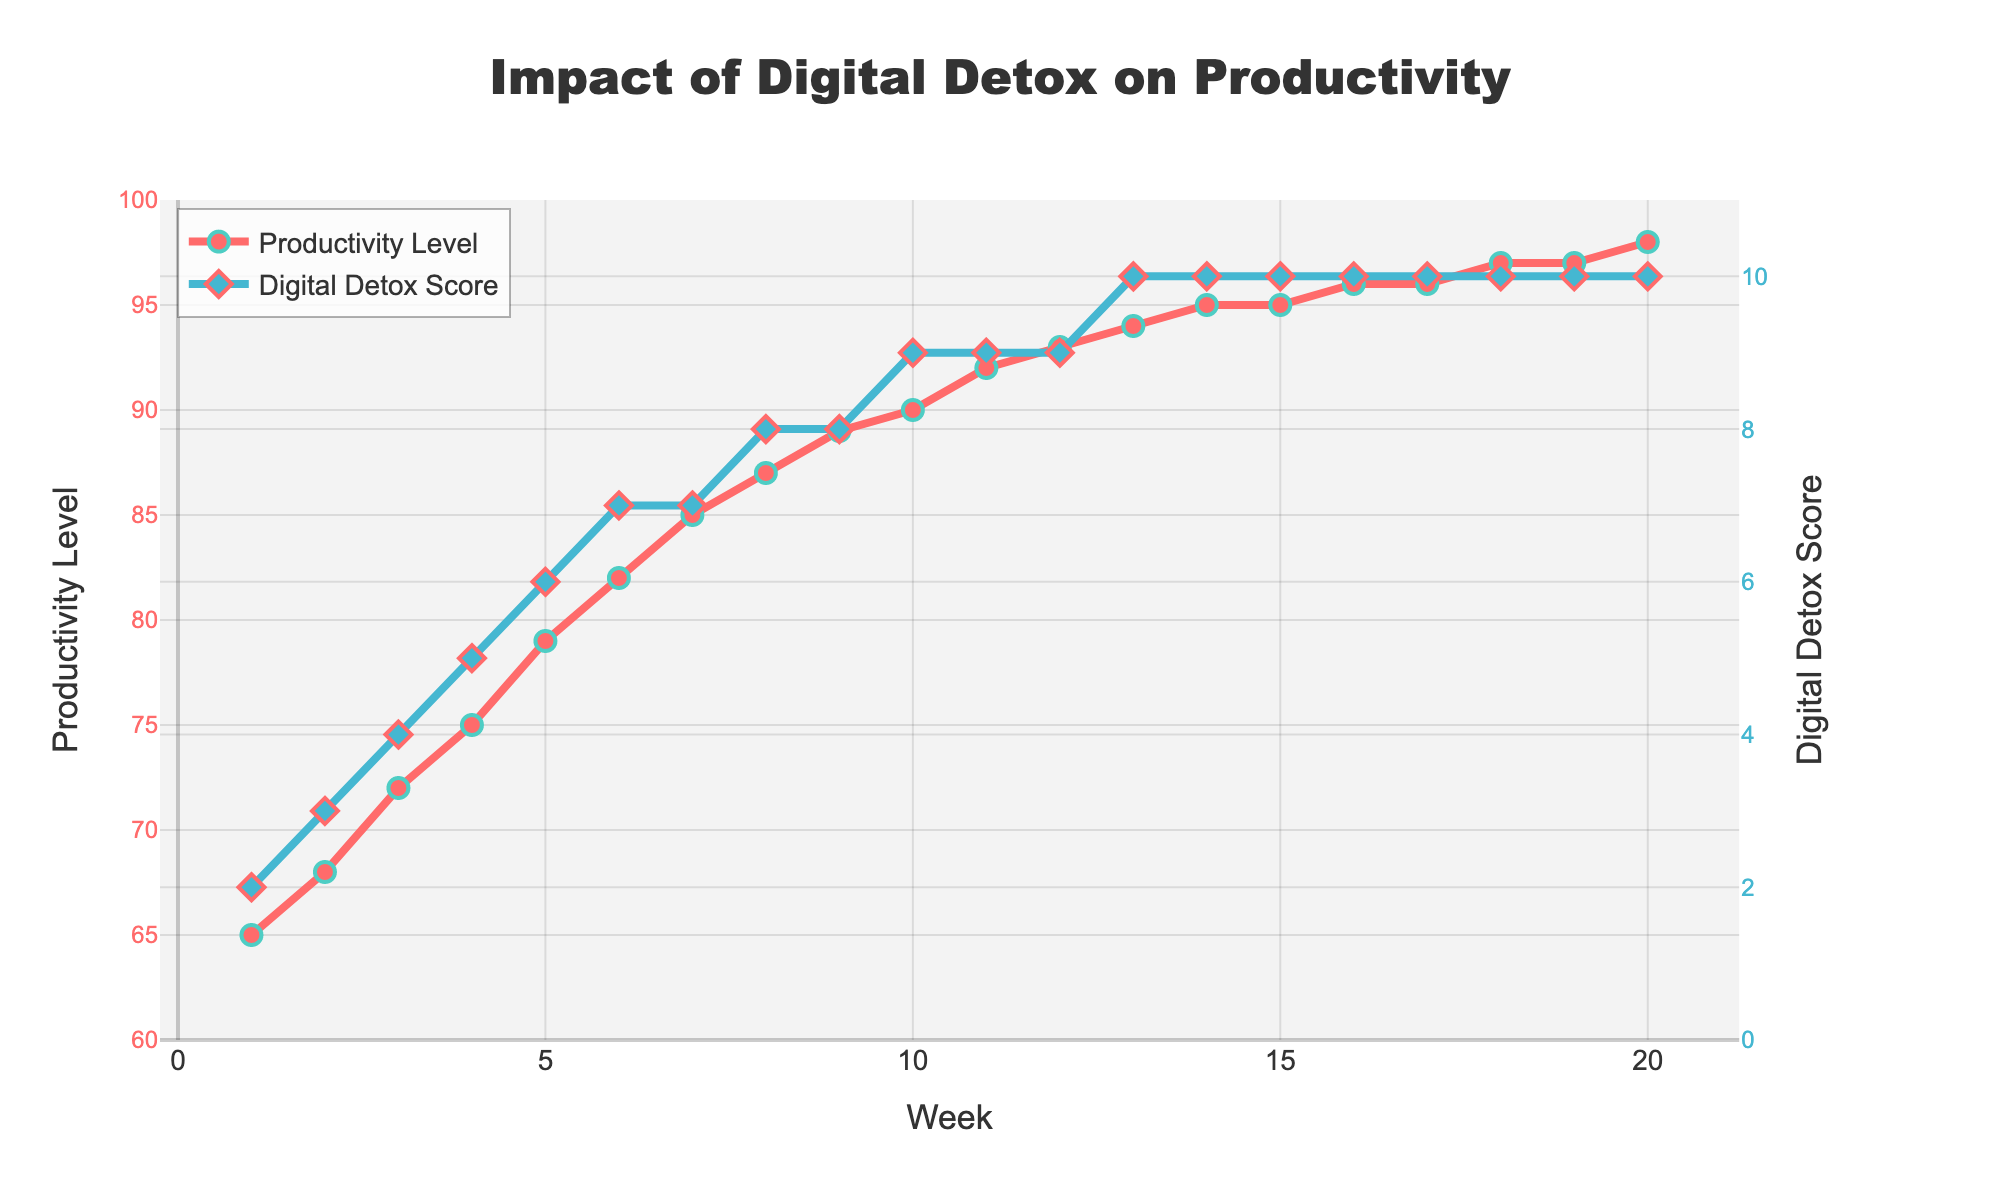What week saw the highest productivity level? By examining the chart, we see that the highest productivity level reaches 98. This happens at Week 20.
Answer: Week 20 What is the difference in productivity level between Week 1 and Week 20? At Week 1, the productivity level is 65, and at Week 20, it is 98. The difference is 98 - 65, which is 33.
Answer: 33 At what week does the Digital Detox Score reach 7 for the first time? By looking at the chart, the first occurrence of a Digital Detox Score of 7 is at Week 6.
Answer: Week 6 How much did the Productivity Level increase from Week 5 to Week 10? At Week 5, the Productivity Level is 79, and at Week 10, it is 90. The increase is 90 - 79, which is 11.
Answer: 11 Compare the trend lines: Does the Digital Detox Score or the Productivity Level stabilize first? Both lines increase over time, but the Digital Detox Score stabilizes at a score of 10 starting from Week 13, while the Productivity Level continues to increase slightly. Therefore, the Digital Detox Score stabilizes first.
Answer: Digital Detox Score What is the average Digital Detox Score from Week 1 to Week 10? The Digital Detox Scores from Week 1 to Week 10 are (2, 3, 4, 5, 6, 7, 7, 8, 8, 9). Their sum is 59. The average is 59 / 10, which is 5.9.
Answer: 5.9 During which weeks do both the Productivity Level and the Digital Detox Score increase concurrently without stabilizing or dropping? Reviewing the chart, both measures increase without any stabilization or drop from Week 1 to Week 12.
Answer: Weeks 1 to 12 What color represents the Productivity Level line in the chart? The line representing the Productivity Level in the chart is colored red.
Answer: Red Which week shows the smallest increase in Productivity Level compared to the previous week? By observing the weekly increments, the smallest increase in Productivity Level happens from Week 15 to Week 16, where it only increases from 95 to 96, a difference of 1.
Answer: Week 15 to Week 16 What is the overall trend in the Productivity Level as the Digital Detox Score increases? The trend shows a steady increase in Productivity Level as the Digital Detox Score increases. This indicates a positive correlation between Digital Detox practices and Productivity Level over the given period.
Answer: Steady increase 